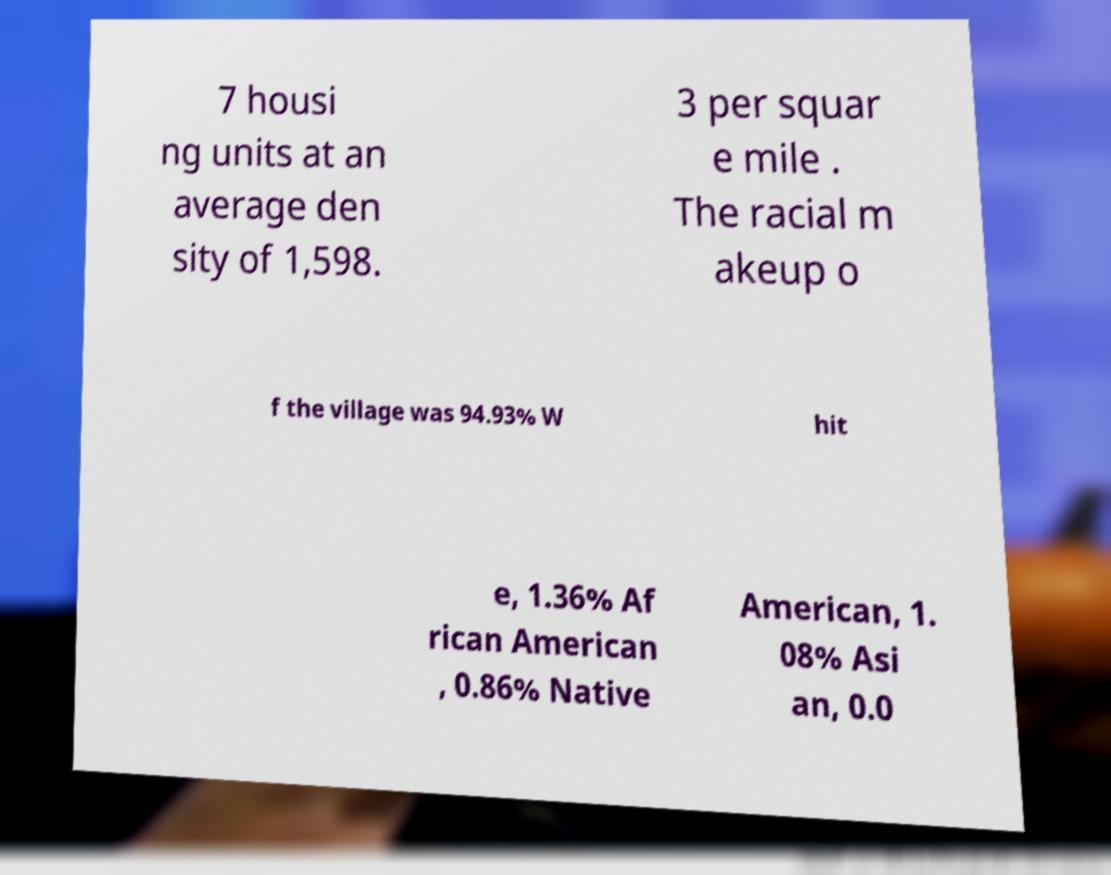What messages or text are displayed in this image? I need them in a readable, typed format. 7 housi ng units at an average den sity of 1,598. 3 per squar e mile . The racial m akeup o f the village was 94.93% W hit e, 1.36% Af rican American , 0.86% Native American, 1. 08% Asi an, 0.0 